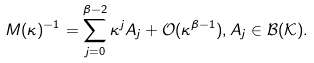<formula> <loc_0><loc_0><loc_500><loc_500>M ( \kappa ) ^ { - 1 } = \sum _ { j = 0 } ^ { \beta - 2 } \kappa ^ { j } A _ { j } + \mathcal { O } ( \kappa ^ { \beta - 1 } ) , A _ { j } \in \mathcal { B } ( \mathcal { K } ) .</formula> 